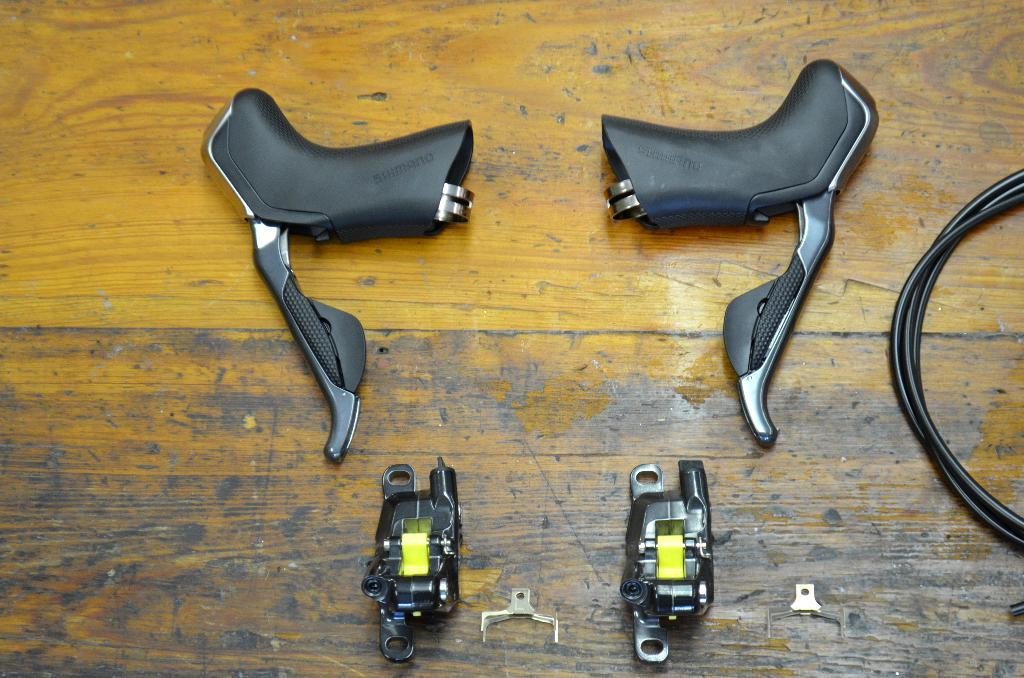What type of objects have handles in the image? The objects with handles in the image are likely tools or equipment. What else can be seen in the image besides the handles? There are wires and other iron equipment visible in the image. Where are these objects located? These objects are on a table. What type of body is visible in the image? There is no body present in the image; it features handles, wires, and other iron equipment on a table. What is the ice used for in the image? There is no ice present in the image. 